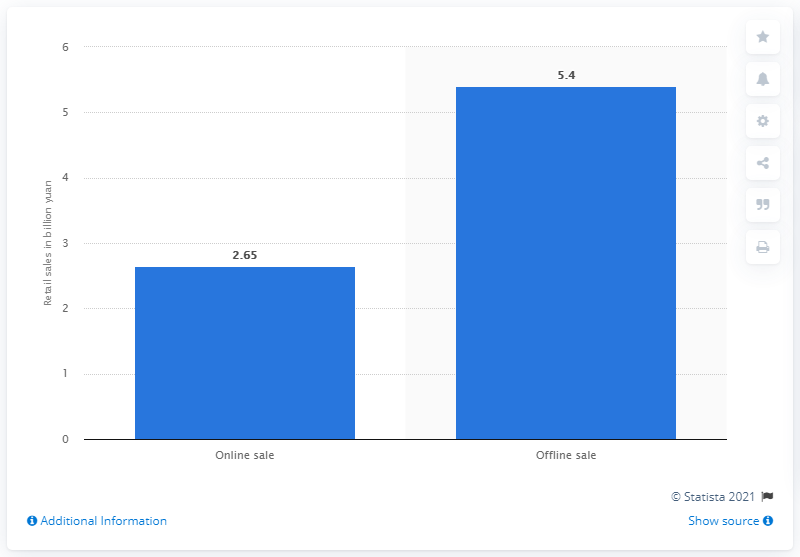Give some essential details in this illustration. In 2016, the retail sales value of contact lenses and care products in China was approximately 5.4 billion dollars. 